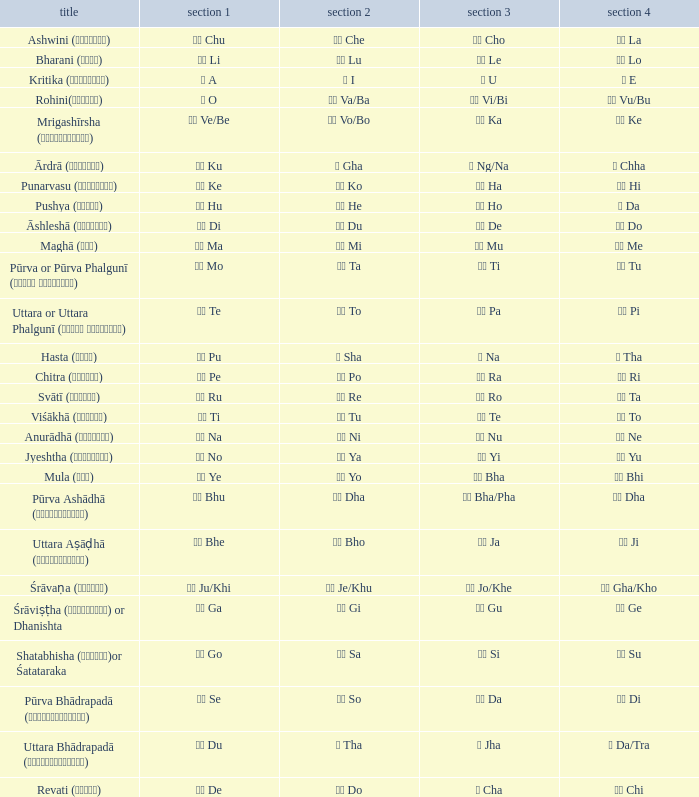What kind of Pada 4 has a Pada 1 of खी ju/khi? खो Gha/Kho. 